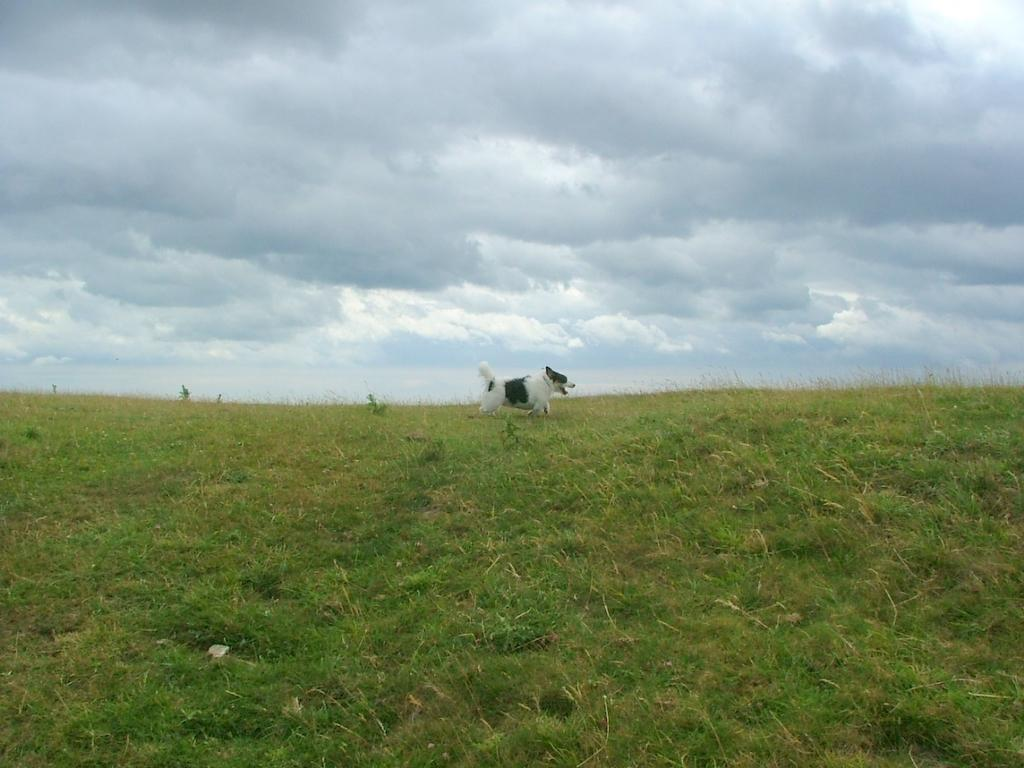What type of animal is in the image? There is a dog in the image. Where is the dog located in the image? The dog is on the ground. What can be seen in the background of the image? The sky is visible in the background of the image. What is the condition of the sky in the image? Clouds are present in the sky. What type of adjustment is the dog making in the image? There is no indication in the image that the dog is making any adjustments. 